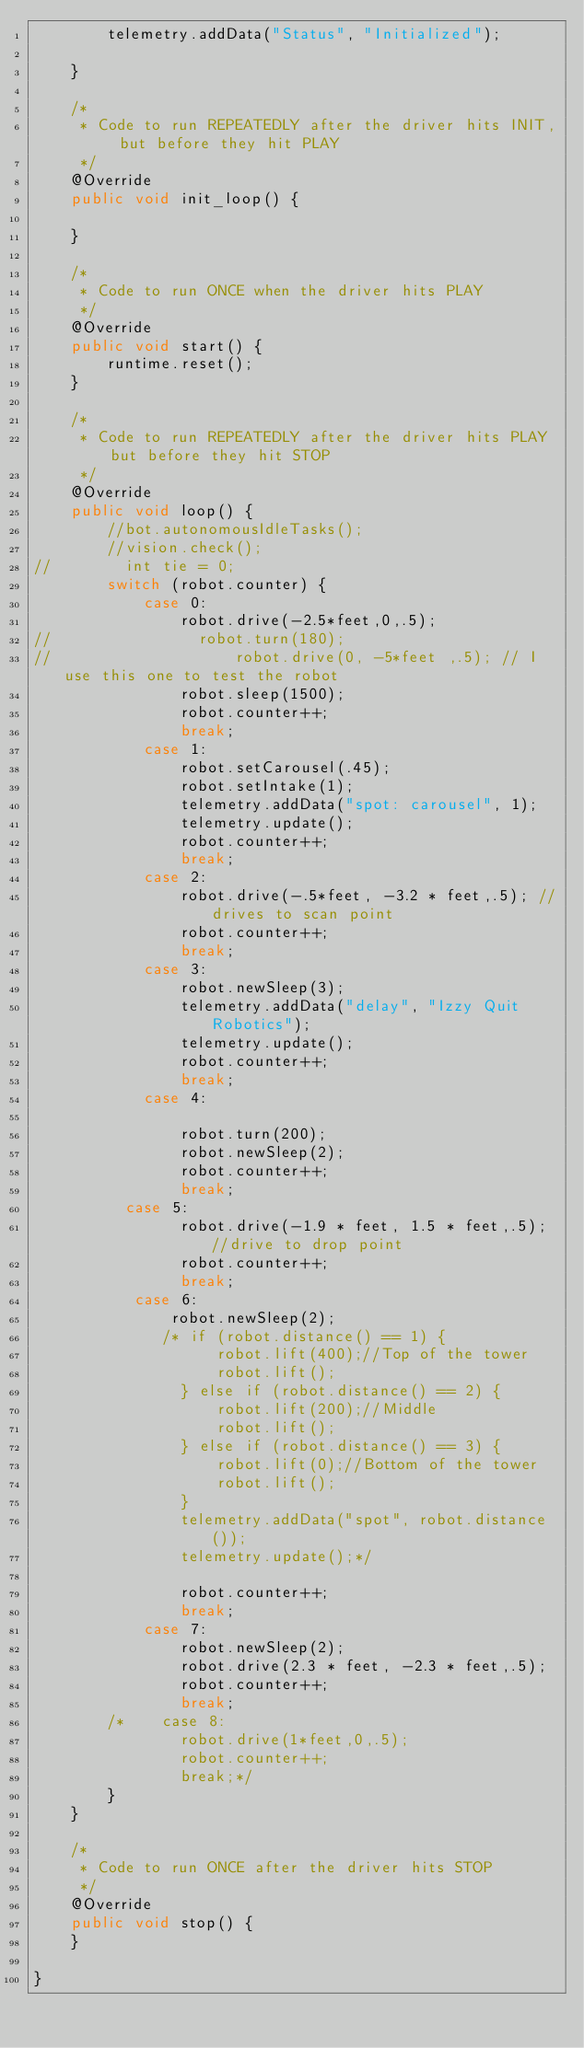Convert code to text. <code><loc_0><loc_0><loc_500><loc_500><_Java_>        telemetry.addData("Status", "Initialized");

    }

    /*
     * Code to run REPEATEDLY after the driver hits INIT, but before they hit PLAY
     */
    @Override
    public void init_loop() {

    }

    /*
     * Code to run ONCE when the driver hits PLAY
     */
    @Override
    public void start() {
        runtime.reset();
    }

    /*
     * Code to run REPEATEDLY after the driver hits PLAY but before they hit STOP
     */
    @Override
    public void loop() {
        //bot.autonomousIdleTasks();
        //vision.check();
//        int tie = 0;
        switch (robot.counter) {
            case 0:
                robot.drive(-2.5*feet,0,.5);
//                robot.turn(180);
//                    robot.drive(0, -5*feet ,.5); // I use this one to test the robot
                robot.sleep(1500);
                robot.counter++;
                break;
            case 1:
                robot.setCarousel(.45);
                robot.setIntake(1);
                telemetry.addData("spot: carousel", 1);
                telemetry.update();
                robot.counter++;
                break;
            case 2:
                robot.drive(-.5*feet, -3.2 * feet,.5); //drives to scan point
                robot.counter++;
                break;
            case 3:
                robot.newSleep(3);
                telemetry.addData("delay", "Izzy Quit Robotics");
                telemetry.update();
                robot.counter++;
                break;
            case 4:

                robot.turn(200);
                robot.newSleep(2);
                robot.counter++;
                break;
          case 5:
                robot.drive(-1.9 * feet, 1.5 * feet,.5); //drive to drop point
                robot.counter++;
                break;
           case 6:
               robot.newSleep(2);
              /* if (robot.distance() == 1) {
                    robot.lift(400);//Top of the tower
                    robot.lift();
                } else if (robot.distance() == 2) {
                    robot.lift(200);//Middle
                    robot.lift();
                } else if (robot.distance() == 3) {
                    robot.lift(0);//Bottom of the tower
                    robot.lift();
                }
                telemetry.addData("spot", robot.distance());
                telemetry.update();*/

                robot.counter++;
                break;
            case 7:
                robot.newSleep(2);
                robot.drive(2.3 * feet, -2.3 * feet,.5);
                robot.counter++;
                break;
        /*    case 8:
                robot.drive(1*feet,0,.5);
                robot.counter++;
                break;*/
        }
    }

    /*
     * Code to run ONCE after the driver hits STOP
     */
    @Override
    public void stop() {
    }

}
</code> 